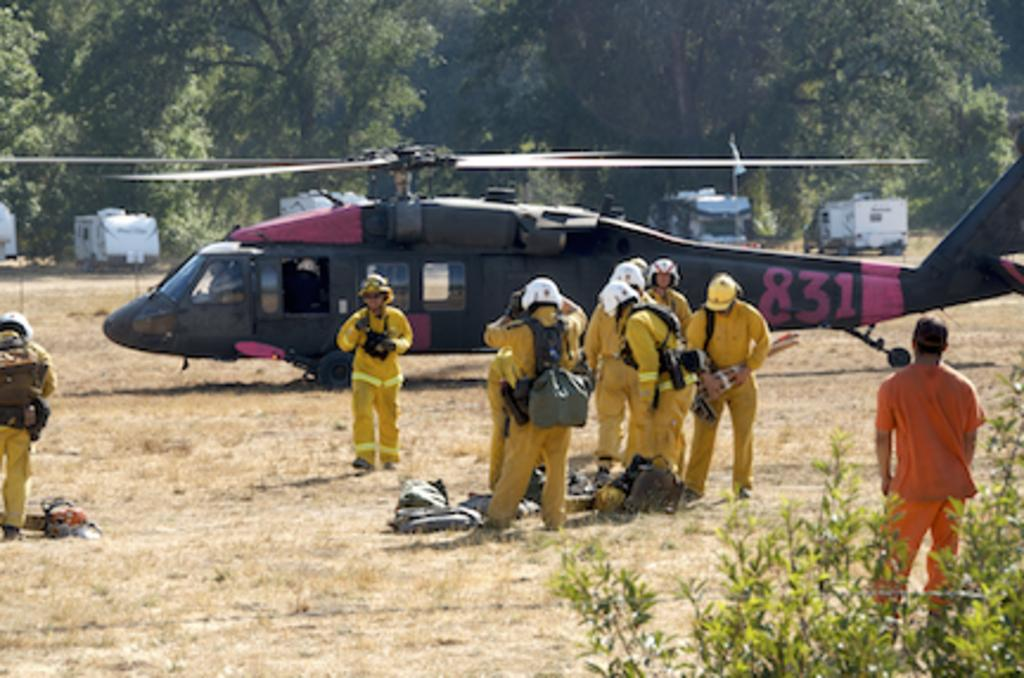<image>
Relay a brief, clear account of the picture shown. a helicopter that has 831 on the back 